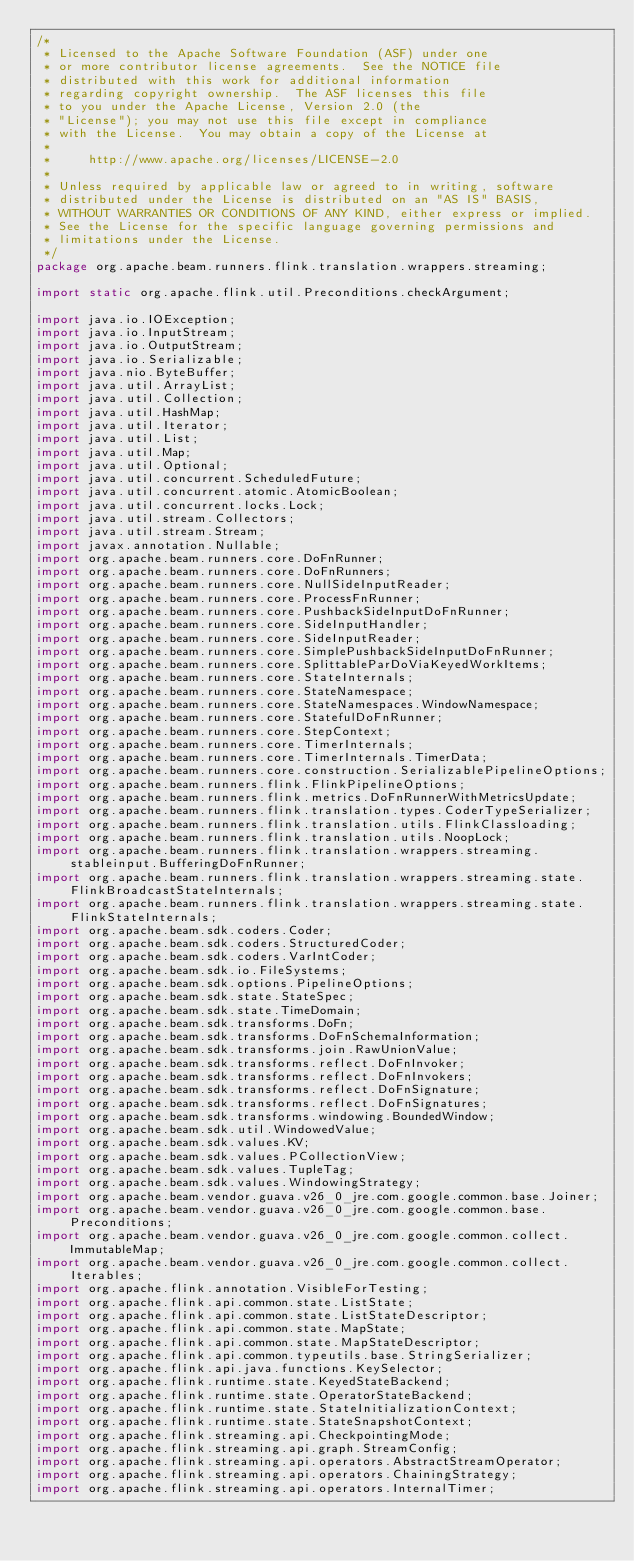Convert code to text. <code><loc_0><loc_0><loc_500><loc_500><_Java_>/*
 * Licensed to the Apache Software Foundation (ASF) under one
 * or more contributor license agreements.  See the NOTICE file
 * distributed with this work for additional information
 * regarding copyright ownership.  The ASF licenses this file
 * to you under the Apache License, Version 2.0 (the
 * "License"); you may not use this file except in compliance
 * with the License.  You may obtain a copy of the License at
 *
 *     http://www.apache.org/licenses/LICENSE-2.0
 *
 * Unless required by applicable law or agreed to in writing, software
 * distributed under the License is distributed on an "AS IS" BASIS,
 * WITHOUT WARRANTIES OR CONDITIONS OF ANY KIND, either express or implied.
 * See the License for the specific language governing permissions and
 * limitations under the License.
 */
package org.apache.beam.runners.flink.translation.wrappers.streaming;

import static org.apache.flink.util.Preconditions.checkArgument;

import java.io.IOException;
import java.io.InputStream;
import java.io.OutputStream;
import java.io.Serializable;
import java.nio.ByteBuffer;
import java.util.ArrayList;
import java.util.Collection;
import java.util.HashMap;
import java.util.Iterator;
import java.util.List;
import java.util.Map;
import java.util.Optional;
import java.util.concurrent.ScheduledFuture;
import java.util.concurrent.atomic.AtomicBoolean;
import java.util.concurrent.locks.Lock;
import java.util.stream.Collectors;
import java.util.stream.Stream;
import javax.annotation.Nullable;
import org.apache.beam.runners.core.DoFnRunner;
import org.apache.beam.runners.core.DoFnRunners;
import org.apache.beam.runners.core.NullSideInputReader;
import org.apache.beam.runners.core.ProcessFnRunner;
import org.apache.beam.runners.core.PushbackSideInputDoFnRunner;
import org.apache.beam.runners.core.SideInputHandler;
import org.apache.beam.runners.core.SideInputReader;
import org.apache.beam.runners.core.SimplePushbackSideInputDoFnRunner;
import org.apache.beam.runners.core.SplittableParDoViaKeyedWorkItems;
import org.apache.beam.runners.core.StateInternals;
import org.apache.beam.runners.core.StateNamespace;
import org.apache.beam.runners.core.StateNamespaces.WindowNamespace;
import org.apache.beam.runners.core.StatefulDoFnRunner;
import org.apache.beam.runners.core.StepContext;
import org.apache.beam.runners.core.TimerInternals;
import org.apache.beam.runners.core.TimerInternals.TimerData;
import org.apache.beam.runners.core.construction.SerializablePipelineOptions;
import org.apache.beam.runners.flink.FlinkPipelineOptions;
import org.apache.beam.runners.flink.metrics.DoFnRunnerWithMetricsUpdate;
import org.apache.beam.runners.flink.translation.types.CoderTypeSerializer;
import org.apache.beam.runners.flink.translation.utils.FlinkClassloading;
import org.apache.beam.runners.flink.translation.utils.NoopLock;
import org.apache.beam.runners.flink.translation.wrappers.streaming.stableinput.BufferingDoFnRunner;
import org.apache.beam.runners.flink.translation.wrappers.streaming.state.FlinkBroadcastStateInternals;
import org.apache.beam.runners.flink.translation.wrappers.streaming.state.FlinkStateInternals;
import org.apache.beam.sdk.coders.Coder;
import org.apache.beam.sdk.coders.StructuredCoder;
import org.apache.beam.sdk.coders.VarIntCoder;
import org.apache.beam.sdk.io.FileSystems;
import org.apache.beam.sdk.options.PipelineOptions;
import org.apache.beam.sdk.state.StateSpec;
import org.apache.beam.sdk.state.TimeDomain;
import org.apache.beam.sdk.transforms.DoFn;
import org.apache.beam.sdk.transforms.DoFnSchemaInformation;
import org.apache.beam.sdk.transforms.join.RawUnionValue;
import org.apache.beam.sdk.transforms.reflect.DoFnInvoker;
import org.apache.beam.sdk.transforms.reflect.DoFnInvokers;
import org.apache.beam.sdk.transforms.reflect.DoFnSignature;
import org.apache.beam.sdk.transforms.reflect.DoFnSignatures;
import org.apache.beam.sdk.transforms.windowing.BoundedWindow;
import org.apache.beam.sdk.util.WindowedValue;
import org.apache.beam.sdk.values.KV;
import org.apache.beam.sdk.values.PCollectionView;
import org.apache.beam.sdk.values.TupleTag;
import org.apache.beam.sdk.values.WindowingStrategy;
import org.apache.beam.vendor.guava.v26_0_jre.com.google.common.base.Joiner;
import org.apache.beam.vendor.guava.v26_0_jre.com.google.common.base.Preconditions;
import org.apache.beam.vendor.guava.v26_0_jre.com.google.common.collect.ImmutableMap;
import org.apache.beam.vendor.guava.v26_0_jre.com.google.common.collect.Iterables;
import org.apache.flink.annotation.VisibleForTesting;
import org.apache.flink.api.common.state.ListState;
import org.apache.flink.api.common.state.ListStateDescriptor;
import org.apache.flink.api.common.state.MapState;
import org.apache.flink.api.common.state.MapStateDescriptor;
import org.apache.flink.api.common.typeutils.base.StringSerializer;
import org.apache.flink.api.java.functions.KeySelector;
import org.apache.flink.runtime.state.KeyedStateBackend;
import org.apache.flink.runtime.state.OperatorStateBackend;
import org.apache.flink.runtime.state.StateInitializationContext;
import org.apache.flink.runtime.state.StateSnapshotContext;
import org.apache.flink.streaming.api.CheckpointingMode;
import org.apache.flink.streaming.api.graph.StreamConfig;
import org.apache.flink.streaming.api.operators.AbstractStreamOperator;
import org.apache.flink.streaming.api.operators.ChainingStrategy;
import org.apache.flink.streaming.api.operators.InternalTimer;</code> 